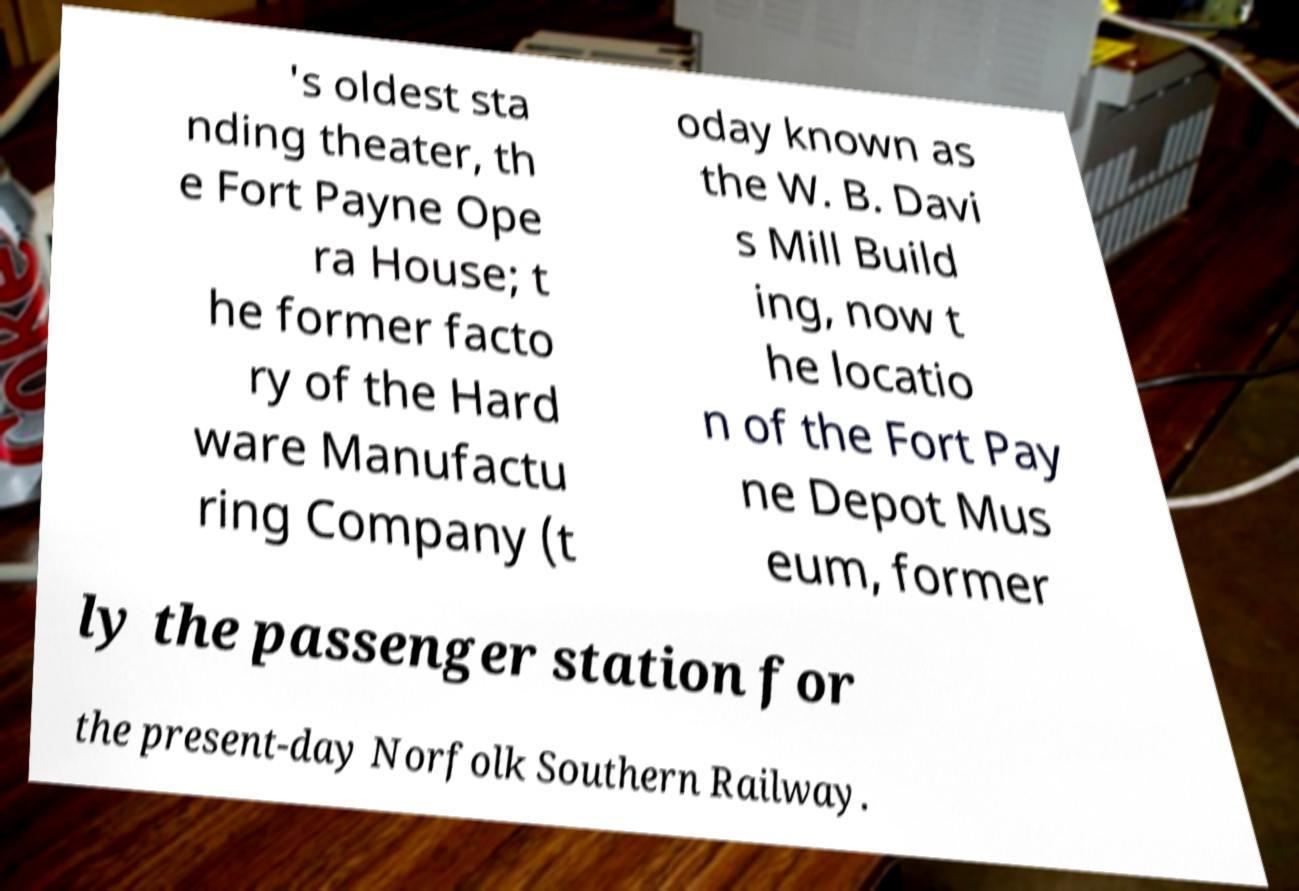For documentation purposes, I need the text within this image transcribed. Could you provide that? 's oldest sta nding theater, th e Fort Payne Ope ra House; t he former facto ry of the Hard ware Manufactu ring Company (t oday known as the W. B. Davi s Mill Build ing, now t he locatio n of the Fort Pay ne Depot Mus eum, former ly the passenger station for the present-day Norfolk Southern Railway. 